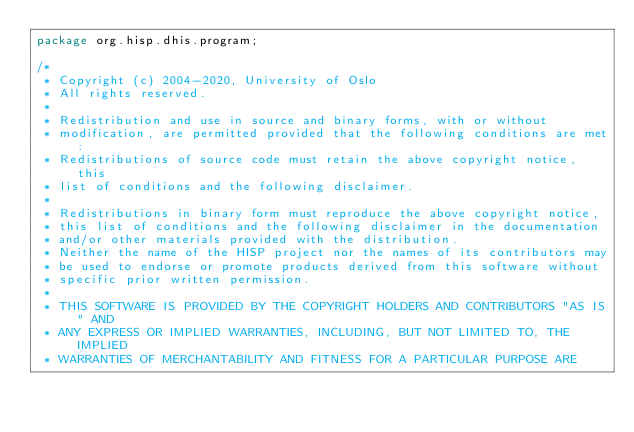<code> <loc_0><loc_0><loc_500><loc_500><_Java_>package org.hisp.dhis.program;

/*
 * Copyright (c) 2004-2020, University of Oslo
 * All rights reserved.
 *
 * Redistribution and use in source and binary forms, with or without
 * modification, are permitted provided that the following conditions are met:
 * Redistributions of source code must retain the above copyright notice, this
 * list of conditions and the following disclaimer.
 *
 * Redistributions in binary form must reproduce the above copyright notice,
 * this list of conditions and the following disclaimer in the documentation
 * and/or other materials provided with the distribution.
 * Neither the name of the HISP project nor the names of its contributors may
 * be used to endorse or promote products derived from this software without
 * specific prior written permission.
 *
 * THIS SOFTWARE IS PROVIDED BY THE COPYRIGHT HOLDERS AND CONTRIBUTORS "AS IS" AND
 * ANY EXPRESS OR IMPLIED WARRANTIES, INCLUDING, BUT NOT LIMITED TO, THE IMPLIED
 * WARRANTIES OF MERCHANTABILITY AND FITNESS FOR A PARTICULAR PURPOSE ARE</code> 